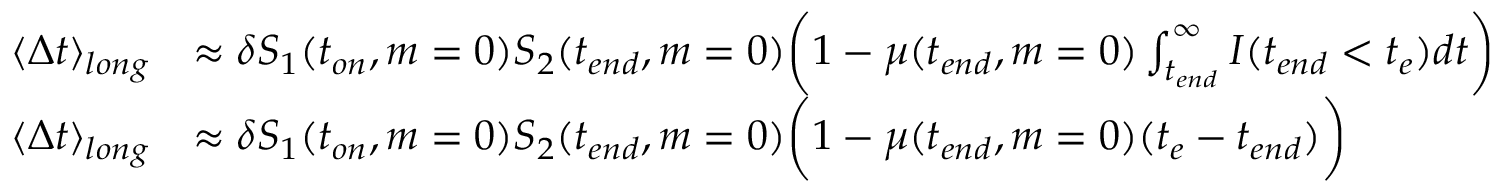<formula> <loc_0><loc_0><loc_500><loc_500>\begin{array} { r l } { \langle \Delta t \rangle _ { l o n g } } & { \approx \delta S _ { 1 } ( t _ { o n } , m = 0 ) S _ { 2 } ( t _ { e n d } , m = 0 ) \left ( 1 - \mu ( t _ { e n d } , m = 0 ) \int _ { t _ { e n d } } ^ { \infty } I ( t _ { e n d } < t _ { e } ) d t \right ) } \\ { \langle \Delta t \rangle _ { l o n g } } & { \approx \delta S _ { 1 } ( t _ { o n } , m = 0 ) S _ { 2 } ( t _ { e n d } , m = 0 ) \left ( 1 - \mu ( t _ { e n d } , m = 0 ) ( t _ { e } - t _ { e n d } ) \right ) } \end{array}</formula> 